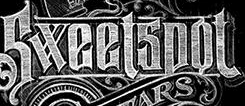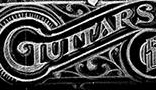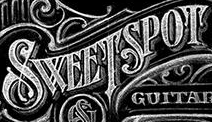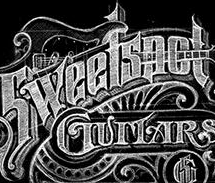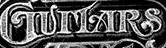What words are shown in these images in order, separated by a semicolon? Sweetspot; GUITARS; SWEETSPOT; Sweetspot; GUITARS 